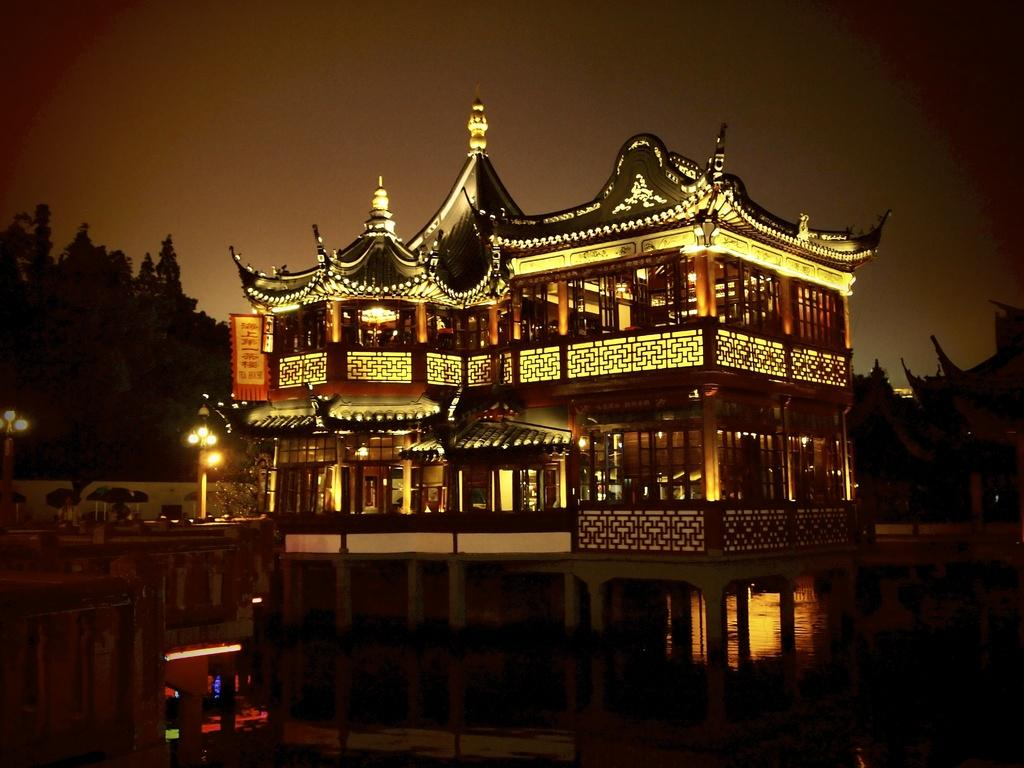What type of building is in the image? There is a palace in the image. What can be seen in the sky in the image? The sky is visible in the image. What type of structures are present along the streets in the image? There are street poles and street lights in the image. What natural element is visible in the image? There is water visible in the image. What type of vegetation is present in the image? There are trees in the image. Can you see the donkey smiling in the image? There is no donkey or any indication of a smile in the image. 